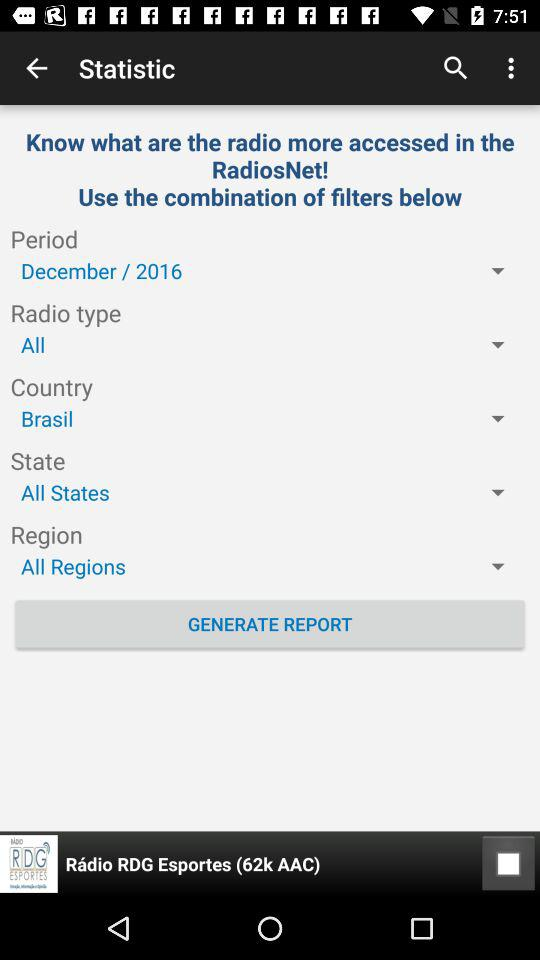What country is chosen? The chosen country is Brazil. 